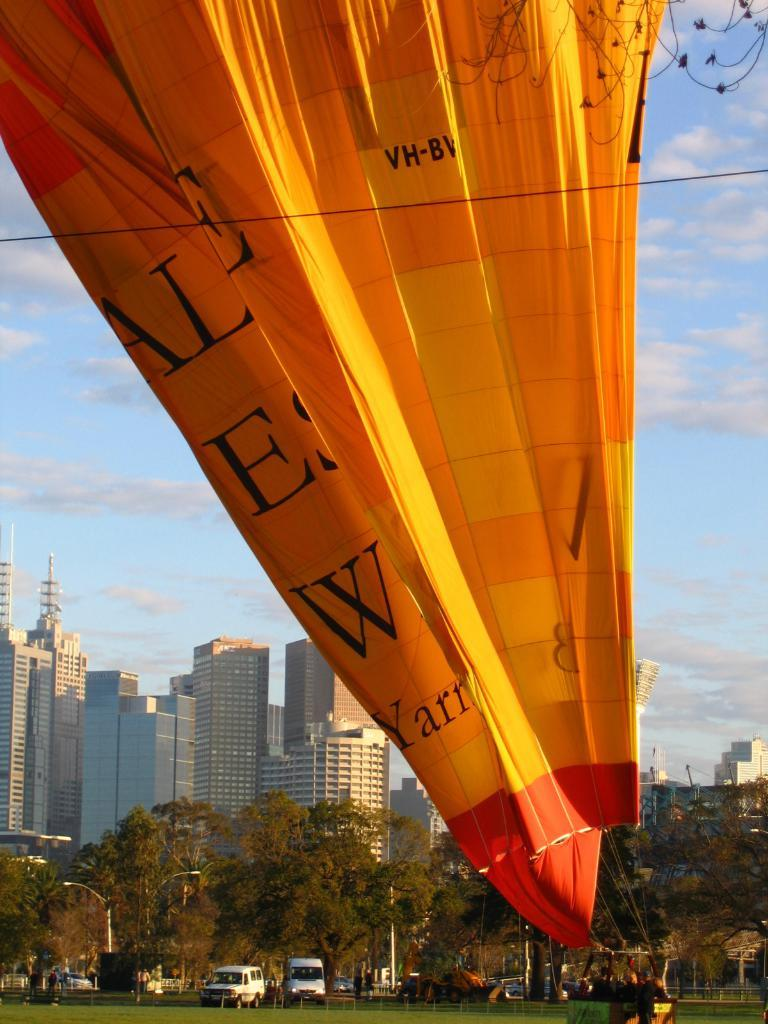What type of structures can be seen in the image? There are buildings in the image. What natural elements are present in the image? There are trees and grass visible in the image. What man-made objects can be seen in the image? There are vehicles and a hot air balloon in the image. What is the condition of the sky in the image? The sky is cloudy in the image. What type of polish is being applied to the hot air balloon in the image? There is no mention of polish or any application process in the image; it simply shows a hot air balloon. How does the holiday affect the image? There is no indication of a holiday or any holiday-related elements in the image. 